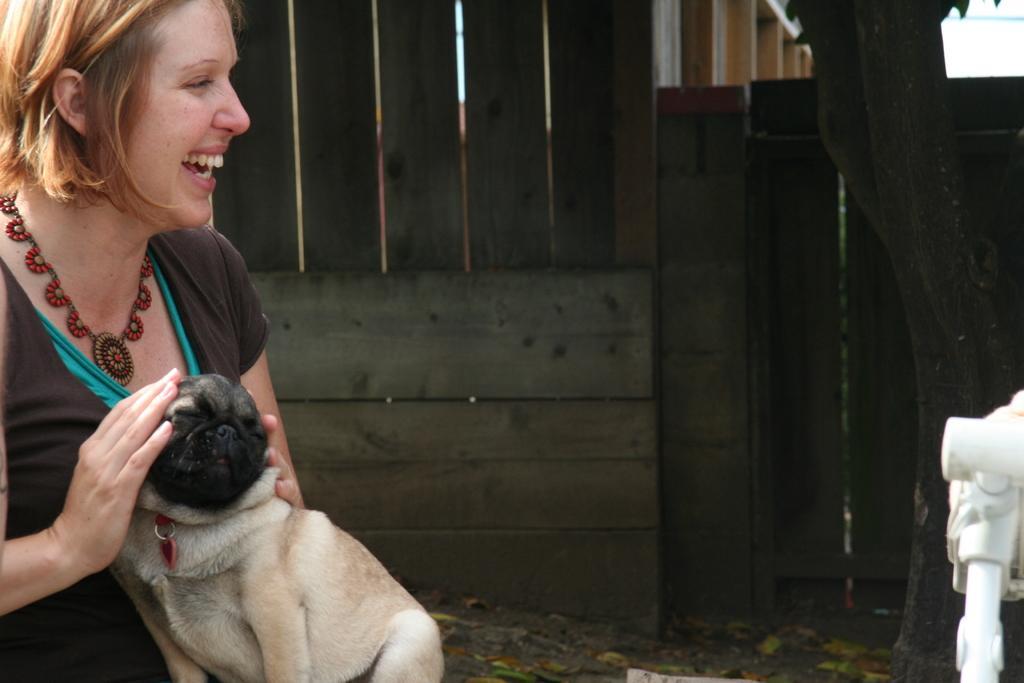Please provide a concise description of this image. there is woman catching a dog and laughing. 